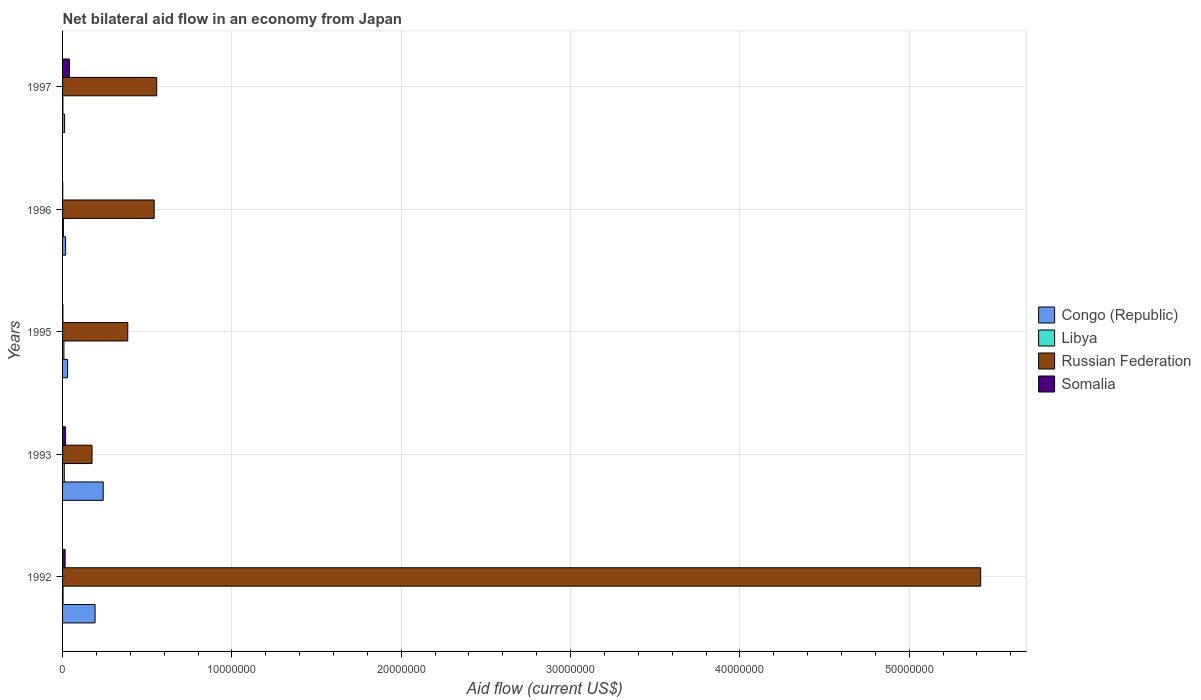How many bars are there on the 3rd tick from the bottom?
Keep it short and to the point. 4. What is the net bilateral aid flow in Congo (Republic) in 1996?
Ensure brevity in your answer.  1.80e+05. Across all years, what is the maximum net bilateral aid flow in Congo (Republic)?
Your response must be concise. 2.40e+06. In which year was the net bilateral aid flow in Russian Federation minimum?
Your response must be concise. 1993. What is the total net bilateral aid flow in Congo (Republic) in the graph?
Your answer should be compact. 4.92e+06. What is the average net bilateral aid flow in Russian Federation per year?
Ensure brevity in your answer.  1.42e+07. In the year 1993, what is the difference between the net bilateral aid flow in Congo (Republic) and net bilateral aid flow in Libya?
Offer a very short reply. 2.30e+06. In how many years, is the net bilateral aid flow in Russian Federation greater than 46000000 US$?
Your answer should be compact. 1. What is the ratio of the net bilateral aid flow in Congo (Republic) in 1993 to that in 1995?
Provide a short and direct response. 8. Is the net bilateral aid flow in Russian Federation in 1992 less than that in 1996?
Provide a short and direct response. No. What is the difference between the highest and the second highest net bilateral aid flow in Russian Federation?
Provide a short and direct response. 4.87e+07. What is the difference between the highest and the lowest net bilateral aid flow in Libya?
Your answer should be compact. 8.00e+04. Is the sum of the net bilateral aid flow in Russian Federation in 1992 and 1995 greater than the maximum net bilateral aid flow in Libya across all years?
Make the answer very short. Yes. Is it the case that in every year, the sum of the net bilateral aid flow in Somalia and net bilateral aid flow in Congo (Republic) is greater than the sum of net bilateral aid flow in Libya and net bilateral aid flow in Russian Federation?
Give a very brief answer. Yes. What does the 1st bar from the top in 1995 represents?
Provide a short and direct response. Somalia. What does the 4th bar from the bottom in 1995 represents?
Make the answer very short. Somalia. Are all the bars in the graph horizontal?
Make the answer very short. Yes. Are the values on the major ticks of X-axis written in scientific E-notation?
Your response must be concise. No. Does the graph contain any zero values?
Make the answer very short. No. How are the legend labels stacked?
Your answer should be very brief. Vertical. What is the title of the graph?
Make the answer very short. Net bilateral aid flow in an economy from Japan. Does "Namibia" appear as one of the legend labels in the graph?
Your response must be concise. No. What is the Aid flow (current US$) in Congo (Republic) in 1992?
Your answer should be very brief. 1.92e+06. What is the Aid flow (current US$) of Libya in 1992?
Make the answer very short. 3.00e+04. What is the Aid flow (current US$) in Russian Federation in 1992?
Your answer should be very brief. 5.42e+07. What is the Aid flow (current US$) of Somalia in 1992?
Offer a terse response. 1.50e+05. What is the Aid flow (current US$) in Congo (Republic) in 1993?
Your answer should be very brief. 2.40e+06. What is the Aid flow (current US$) in Libya in 1993?
Keep it short and to the point. 1.00e+05. What is the Aid flow (current US$) of Russian Federation in 1993?
Your answer should be very brief. 1.74e+06. What is the Aid flow (current US$) of Congo (Republic) in 1995?
Ensure brevity in your answer.  3.00e+05. What is the Aid flow (current US$) in Libya in 1995?
Keep it short and to the point. 8.00e+04. What is the Aid flow (current US$) of Russian Federation in 1995?
Provide a short and direct response. 3.85e+06. What is the Aid flow (current US$) of Congo (Republic) in 1996?
Make the answer very short. 1.80e+05. What is the Aid flow (current US$) of Libya in 1996?
Keep it short and to the point. 5.00e+04. What is the Aid flow (current US$) in Russian Federation in 1996?
Keep it short and to the point. 5.41e+06. What is the Aid flow (current US$) of Somalia in 1996?
Give a very brief answer. 10000. What is the Aid flow (current US$) in Russian Federation in 1997?
Provide a short and direct response. 5.56e+06. Across all years, what is the maximum Aid flow (current US$) of Congo (Republic)?
Your answer should be compact. 2.40e+06. Across all years, what is the maximum Aid flow (current US$) in Russian Federation?
Provide a succinct answer. 5.42e+07. Across all years, what is the maximum Aid flow (current US$) in Somalia?
Offer a terse response. 4.00e+05. Across all years, what is the minimum Aid flow (current US$) of Russian Federation?
Your response must be concise. 1.74e+06. What is the total Aid flow (current US$) in Congo (Republic) in the graph?
Offer a very short reply. 4.92e+06. What is the total Aid flow (current US$) of Libya in the graph?
Your answer should be compact. 2.80e+05. What is the total Aid flow (current US$) of Russian Federation in the graph?
Keep it short and to the point. 7.08e+07. What is the total Aid flow (current US$) of Somalia in the graph?
Your answer should be very brief. 7.60e+05. What is the difference between the Aid flow (current US$) in Congo (Republic) in 1992 and that in 1993?
Give a very brief answer. -4.80e+05. What is the difference between the Aid flow (current US$) in Russian Federation in 1992 and that in 1993?
Give a very brief answer. 5.25e+07. What is the difference between the Aid flow (current US$) in Somalia in 1992 and that in 1993?
Provide a succinct answer. -3.00e+04. What is the difference between the Aid flow (current US$) in Congo (Republic) in 1992 and that in 1995?
Keep it short and to the point. 1.62e+06. What is the difference between the Aid flow (current US$) in Libya in 1992 and that in 1995?
Your answer should be very brief. -5.00e+04. What is the difference between the Aid flow (current US$) in Russian Federation in 1992 and that in 1995?
Provide a short and direct response. 5.04e+07. What is the difference between the Aid flow (current US$) in Congo (Republic) in 1992 and that in 1996?
Give a very brief answer. 1.74e+06. What is the difference between the Aid flow (current US$) of Libya in 1992 and that in 1996?
Keep it short and to the point. -2.00e+04. What is the difference between the Aid flow (current US$) in Russian Federation in 1992 and that in 1996?
Your response must be concise. 4.88e+07. What is the difference between the Aid flow (current US$) in Congo (Republic) in 1992 and that in 1997?
Keep it short and to the point. 1.80e+06. What is the difference between the Aid flow (current US$) in Russian Federation in 1992 and that in 1997?
Your response must be concise. 4.87e+07. What is the difference between the Aid flow (current US$) of Somalia in 1992 and that in 1997?
Give a very brief answer. -2.50e+05. What is the difference between the Aid flow (current US$) in Congo (Republic) in 1993 and that in 1995?
Keep it short and to the point. 2.10e+06. What is the difference between the Aid flow (current US$) in Russian Federation in 1993 and that in 1995?
Your answer should be compact. -2.11e+06. What is the difference between the Aid flow (current US$) in Somalia in 1993 and that in 1995?
Ensure brevity in your answer.  1.60e+05. What is the difference between the Aid flow (current US$) in Congo (Republic) in 1993 and that in 1996?
Provide a short and direct response. 2.22e+06. What is the difference between the Aid flow (current US$) of Libya in 1993 and that in 1996?
Ensure brevity in your answer.  5.00e+04. What is the difference between the Aid flow (current US$) of Russian Federation in 1993 and that in 1996?
Make the answer very short. -3.67e+06. What is the difference between the Aid flow (current US$) of Congo (Republic) in 1993 and that in 1997?
Your answer should be compact. 2.28e+06. What is the difference between the Aid flow (current US$) of Russian Federation in 1993 and that in 1997?
Your answer should be compact. -3.82e+06. What is the difference between the Aid flow (current US$) of Congo (Republic) in 1995 and that in 1996?
Your response must be concise. 1.20e+05. What is the difference between the Aid flow (current US$) in Russian Federation in 1995 and that in 1996?
Your answer should be very brief. -1.56e+06. What is the difference between the Aid flow (current US$) of Somalia in 1995 and that in 1996?
Your answer should be very brief. 10000. What is the difference between the Aid flow (current US$) of Congo (Republic) in 1995 and that in 1997?
Ensure brevity in your answer.  1.80e+05. What is the difference between the Aid flow (current US$) of Libya in 1995 and that in 1997?
Offer a very short reply. 6.00e+04. What is the difference between the Aid flow (current US$) in Russian Federation in 1995 and that in 1997?
Keep it short and to the point. -1.71e+06. What is the difference between the Aid flow (current US$) in Somalia in 1995 and that in 1997?
Your response must be concise. -3.80e+05. What is the difference between the Aid flow (current US$) in Congo (Republic) in 1996 and that in 1997?
Offer a very short reply. 6.00e+04. What is the difference between the Aid flow (current US$) of Libya in 1996 and that in 1997?
Keep it short and to the point. 3.00e+04. What is the difference between the Aid flow (current US$) of Somalia in 1996 and that in 1997?
Provide a succinct answer. -3.90e+05. What is the difference between the Aid flow (current US$) of Congo (Republic) in 1992 and the Aid flow (current US$) of Libya in 1993?
Ensure brevity in your answer.  1.82e+06. What is the difference between the Aid flow (current US$) in Congo (Republic) in 1992 and the Aid flow (current US$) in Somalia in 1993?
Offer a terse response. 1.74e+06. What is the difference between the Aid flow (current US$) of Libya in 1992 and the Aid flow (current US$) of Russian Federation in 1993?
Keep it short and to the point. -1.71e+06. What is the difference between the Aid flow (current US$) in Libya in 1992 and the Aid flow (current US$) in Somalia in 1993?
Offer a terse response. -1.50e+05. What is the difference between the Aid flow (current US$) in Russian Federation in 1992 and the Aid flow (current US$) in Somalia in 1993?
Keep it short and to the point. 5.40e+07. What is the difference between the Aid flow (current US$) in Congo (Republic) in 1992 and the Aid flow (current US$) in Libya in 1995?
Your answer should be compact. 1.84e+06. What is the difference between the Aid flow (current US$) of Congo (Republic) in 1992 and the Aid flow (current US$) of Russian Federation in 1995?
Ensure brevity in your answer.  -1.93e+06. What is the difference between the Aid flow (current US$) in Congo (Republic) in 1992 and the Aid flow (current US$) in Somalia in 1995?
Your answer should be very brief. 1.90e+06. What is the difference between the Aid flow (current US$) in Libya in 1992 and the Aid flow (current US$) in Russian Federation in 1995?
Your response must be concise. -3.82e+06. What is the difference between the Aid flow (current US$) of Russian Federation in 1992 and the Aid flow (current US$) of Somalia in 1995?
Offer a terse response. 5.42e+07. What is the difference between the Aid flow (current US$) in Congo (Republic) in 1992 and the Aid flow (current US$) in Libya in 1996?
Offer a very short reply. 1.87e+06. What is the difference between the Aid flow (current US$) in Congo (Republic) in 1992 and the Aid flow (current US$) in Russian Federation in 1996?
Give a very brief answer. -3.49e+06. What is the difference between the Aid flow (current US$) in Congo (Republic) in 1992 and the Aid flow (current US$) in Somalia in 1996?
Your answer should be compact. 1.91e+06. What is the difference between the Aid flow (current US$) of Libya in 1992 and the Aid flow (current US$) of Russian Federation in 1996?
Offer a very short reply. -5.38e+06. What is the difference between the Aid flow (current US$) of Libya in 1992 and the Aid flow (current US$) of Somalia in 1996?
Provide a short and direct response. 2.00e+04. What is the difference between the Aid flow (current US$) in Russian Federation in 1992 and the Aid flow (current US$) in Somalia in 1996?
Offer a very short reply. 5.42e+07. What is the difference between the Aid flow (current US$) of Congo (Republic) in 1992 and the Aid flow (current US$) of Libya in 1997?
Provide a succinct answer. 1.90e+06. What is the difference between the Aid flow (current US$) in Congo (Republic) in 1992 and the Aid flow (current US$) in Russian Federation in 1997?
Keep it short and to the point. -3.64e+06. What is the difference between the Aid flow (current US$) in Congo (Republic) in 1992 and the Aid flow (current US$) in Somalia in 1997?
Your answer should be very brief. 1.52e+06. What is the difference between the Aid flow (current US$) of Libya in 1992 and the Aid flow (current US$) of Russian Federation in 1997?
Keep it short and to the point. -5.53e+06. What is the difference between the Aid flow (current US$) in Libya in 1992 and the Aid flow (current US$) in Somalia in 1997?
Keep it short and to the point. -3.70e+05. What is the difference between the Aid flow (current US$) in Russian Federation in 1992 and the Aid flow (current US$) in Somalia in 1997?
Your answer should be very brief. 5.38e+07. What is the difference between the Aid flow (current US$) of Congo (Republic) in 1993 and the Aid flow (current US$) of Libya in 1995?
Offer a very short reply. 2.32e+06. What is the difference between the Aid flow (current US$) in Congo (Republic) in 1993 and the Aid flow (current US$) in Russian Federation in 1995?
Your answer should be very brief. -1.45e+06. What is the difference between the Aid flow (current US$) of Congo (Republic) in 1993 and the Aid flow (current US$) of Somalia in 1995?
Offer a terse response. 2.38e+06. What is the difference between the Aid flow (current US$) in Libya in 1993 and the Aid flow (current US$) in Russian Federation in 1995?
Offer a terse response. -3.75e+06. What is the difference between the Aid flow (current US$) in Russian Federation in 1993 and the Aid flow (current US$) in Somalia in 1995?
Provide a short and direct response. 1.72e+06. What is the difference between the Aid flow (current US$) in Congo (Republic) in 1993 and the Aid flow (current US$) in Libya in 1996?
Ensure brevity in your answer.  2.35e+06. What is the difference between the Aid flow (current US$) of Congo (Republic) in 1993 and the Aid flow (current US$) of Russian Federation in 1996?
Provide a succinct answer. -3.01e+06. What is the difference between the Aid flow (current US$) of Congo (Republic) in 1993 and the Aid flow (current US$) of Somalia in 1996?
Your response must be concise. 2.39e+06. What is the difference between the Aid flow (current US$) in Libya in 1993 and the Aid flow (current US$) in Russian Federation in 1996?
Ensure brevity in your answer.  -5.31e+06. What is the difference between the Aid flow (current US$) of Russian Federation in 1993 and the Aid flow (current US$) of Somalia in 1996?
Provide a succinct answer. 1.73e+06. What is the difference between the Aid flow (current US$) in Congo (Republic) in 1993 and the Aid flow (current US$) in Libya in 1997?
Provide a succinct answer. 2.38e+06. What is the difference between the Aid flow (current US$) in Congo (Republic) in 1993 and the Aid flow (current US$) in Russian Federation in 1997?
Your answer should be compact. -3.16e+06. What is the difference between the Aid flow (current US$) in Congo (Republic) in 1993 and the Aid flow (current US$) in Somalia in 1997?
Offer a terse response. 2.00e+06. What is the difference between the Aid flow (current US$) in Libya in 1993 and the Aid flow (current US$) in Russian Federation in 1997?
Provide a short and direct response. -5.46e+06. What is the difference between the Aid flow (current US$) of Russian Federation in 1993 and the Aid flow (current US$) of Somalia in 1997?
Your answer should be very brief. 1.34e+06. What is the difference between the Aid flow (current US$) of Congo (Republic) in 1995 and the Aid flow (current US$) of Russian Federation in 1996?
Your answer should be compact. -5.11e+06. What is the difference between the Aid flow (current US$) of Libya in 1995 and the Aid flow (current US$) of Russian Federation in 1996?
Your answer should be compact. -5.33e+06. What is the difference between the Aid flow (current US$) of Libya in 1995 and the Aid flow (current US$) of Somalia in 1996?
Your answer should be compact. 7.00e+04. What is the difference between the Aid flow (current US$) of Russian Federation in 1995 and the Aid flow (current US$) of Somalia in 1996?
Keep it short and to the point. 3.84e+06. What is the difference between the Aid flow (current US$) of Congo (Republic) in 1995 and the Aid flow (current US$) of Russian Federation in 1997?
Make the answer very short. -5.26e+06. What is the difference between the Aid flow (current US$) in Libya in 1995 and the Aid flow (current US$) in Russian Federation in 1997?
Keep it short and to the point. -5.48e+06. What is the difference between the Aid flow (current US$) in Libya in 1995 and the Aid flow (current US$) in Somalia in 1997?
Offer a terse response. -3.20e+05. What is the difference between the Aid flow (current US$) of Russian Federation in 1995 and the Aid flow (current US$) of Somalia in 1997?
Keep it short and to the point. 3.45e+06. What is the difference between the Aid flow (current US$) in Congo (Republic) in 1996 and the Aid flow (current US$) in Russian Federation in 1997?
Offer a terse response. -5.38e+06. What is the difference between the Aid flow (current US$) of Libya in 1996 and the Aid flow (current US$) of Russian Federation in 1997?
Your response must be concise. -5.51e+06. What is the difference between the Aid flow (current US$) in Libya in 1996 and the Aid flow (current US$) in Somalia in 1997?
Ensure brevity in your answer.  -3.50e+05. What is the difference between the Aid flow (current US$) in Russian Federation in 1996 and the Aid flow (current US$) in Somalia in 1997?
Provide a short and direct response. 5.01e+06. What is the average Aid flow (current US$) of Congo (Republic) per year?
Your response must be concise. 9.84e+05. What is the average Aid flow (current US$) of Libya per year?
Make the answer very short. 5.60e+04. What is the average Aid flow (current US$) in Russian Federation per year?
Your answer should be compact. 1.42e+07. What is the average Aid flow (current US$) in Somalia per year?
Give a very brief answer. 1.52e+05. In the year 1992, what is the difference between the Aid flow (current US$) in Congo (Republic) and Aid flow (current US$) in Libya?
Your answer should be compact. 1.89e+06. In the year 1992, what is the difference between the Aid flow (current US$) of Congo (Republic) and Aid flow (current US$) of Russian Federation?
Give a very brief answer. -5.23e+07. In the year 1992, what is the difference between the Aid flow (current US$) of Congo (Republic) and Aid flow (current US$) of Somalia?
Keep it short and to the point. 1.77e+06. In the year 1992, what is the difference between the Aid flow (current US$) in Libya and Aid flow (current US$) in Russian Federation?
Your answer should be very brief. -5.42e+07. In the year 1992, what is the difference between the Aid flow (current US$) of Russian Federation and Aid flow (current US$) of Somalia?
Your answer should be very brief. 5.41e+07. In the year 1993, what is the difference between the Aid flow (current US$) in Congo (Republic) and Aid flow (current US$) in Libya?
Ensure brevity in your answer.  2.30e+06. In the year 1993, what is the difference between the Aid flow (current US$) in Congo (Republic) and Aid flow (current US$) in Somalia?
Offer a terse response. 2.22e+06. In the year 1993, what is the difference between the Aid flow (current US$) in Libya and Aid flow (current US$) in Russian Federation?
Provide a succinct answer. -1.64e+06. In the year 1993, what is the difference between the Aid flow (current US$) of Libya and Aid flow (current US$) of Somalia?
Provide a succinct answer. -8.00e+04. In the year 1993, what is the difference between the Aid flow (current US$) in Russian Federation and Aid flow (current US$) in Somalia?
Your response must be concise. 1.56e+06. In the year 1995, what is the difference between the Aid flow (current US$) in Congo (Republic) and Aid flow (current US$) in Russian Federation?
Your answer should be very brief. -3.55e+06. In the year 1995, what is the difference between the Aid flow (current US$) of Libya and Aid flow (current US$) of Russian Federation?
Provide a succinct answer. -3.77e+06. In the year 1995, what is the difference between the Aid flow (current US$) of Libya and Aid flow (current US$) of Somalia?
Offer a very short reply. 6.00e+04. In the year 1995, what is the difference between the Aid flow (current US$) in Russian Federation and Aid flow (current US$) in Somalia?
Your response must be concise. 3.83e+06. In the year 1996, what is the difference between the Aid flow (current US$) in Congo (Republic) and Aid flow (current US$) in Libya?
Offer a very short reply. 1.30e+05. In the year 1996, what is the difference between the Aid flow (current US$) of Congo (Republic) and Aid flow (current US$) of Russian Federation?
Keep it short and to the point. -5.23e+06. In the year 1996, what is the difference between the Aid flow (current US$) in Congo (Republic) and Aid flow (current US$) in Somalia?
Ensure brevity in your answer.  1.70e+05. In the year 1996, what is the difference between the Aid flow (current US$) of Libya and Aid flow (current US$) of Russian Federation?
Your answer should be very brief. -5.36e+06. In the year 1996, what is the difference between the Aid flow (current US$) in Russian Federation and Aid flow (current US$) in Somalia?
Ensure brevity in your answer.  5.40e+06. In the year 1997, what is the difference between the Aid flow (current US$) of Congo (Republic) and Aid flow (current US$) of Russian Federation?
Provide a succinct answer. -5.44e+06. In the year 1997, what is the difference between the Aid flow (current US$) in Congo (Republic) and Aid flow (current US$) in Somalia?
Your response must be concise. -2.80e+05. In the year 1997, what is the difference between the Aid flow (current US$) of Libya and Aid flow (current US$) of Russian Federation?
Offer a very short reply. -5.54e+06. In the year 1997, what is the difference between the Aid flow (current US$) of Libya and Aid flow (current US$) of Somalia?
Keep it short and to the point. -3.80e+05. In the year 1997, what is the difference between the Aid flow (current US$) in Russian Federation and Aid flow (current US$) in Somalia?
Offer a very short reply. 5.16e+06. What is the ratio of the Aid flow (current US$) of Congo (Republic) in 1992 to that in 1993?
Keep it short and to the point. 0.8. What is the ratio of the Aid flow (current US$) in Russian Federation in 1992 to that in 1993?
Make the answer very short. 31.16. What is the ratio of the Aid flow (current US$) in Russian Federation in 1992 to that in 1995?
Make the answer very short. 14.08. What is the ratio of the Aid flow (current US$) in Somalia in 1992 to that in 1995?
Provide a succinct answer. 7.5. What is the ratio of the Aid flow (current US$) in Congo (Republic) in 1992 to that in 1996?
Your answer should be very brief. 10.67. What is the ratio of the Aid flow (current US$) in Russian Federation in 1992 to that in 1996?
Ensure brevity in your answer.  10.02. What is the ratio of the Aid flow (current US$) of Congo (Republic) in 1992 to that in 1997?
Offer a terse response. 16. What is the ratio of the Aid flow (current US$) of Russian Federation in 1992 to that in 1997?
Give a very brief answer. 9.75. What is the ratio of the Aid flow (current US$) in Somalia in 1992 to that in 1997?
Provide a short and direct response. 0.38. What is the ratio of the Aid flow (current US$) of Russian Federation in 1993 to that in 1995?
Make the answer very short. 0.45. What is the ratio of the Aid flow (current US$) of Somalia in 1993 to that in 1995?
Make the answer very short. 9. What is the ratio of the Aid flow (current US$) of Congo (Republic) in 1993 to that in 1996?
Your answer should be very brief. 13.33. What is the ratio of the Aid flow (current US$) of Libya in 1993 to that in 1996?
Your answer should be very brief. 2. What is the ratio of the Aid flow (current US$) of Russian Federation in 1993 to that in 1996?
Keep it short and to the point. 0.32. What is the ratio of the Aid flow (current US$) in Somalia in 1993 to that in 1996?
Keep it short and to the point. 18. What is the ratio of the Aid flow (current US$) in Libya in 1993 to that in 1997?
Give a very brief answer. 5. What is the ratio of the Aid flow (current US$) in Russian Federation in 1993 to that in 1997?
Provide a short and direct response. 0.31. What is the ratio of the Aid flow (current US$) in Somalia in 1993 to that in 1997?
Provide a succinct answer. 0.45. What is the ratio of the Aid flow (current US$) in Libya in 1995 to that in 1996?
Offer a terse response. 1.6. What is the ratio of the Aid flow (current US$) of Russian Federation in 1995 to that in 1996?
Keep it short and to the point. 0.71. What is the ratio of the Aid flow (current US$) of Somalia in 1995 to that in 1996?
Your answer should be very brief. 2. What is the ratio of the Aid flow (current US$) in Congo (Republic) in 1995 to that in 1997?
Your answer should be very brief. 2.5. What is the ratio of the Aid flow (current US$) in Russian Federation in 1995 to that in 1997?
Keep it short and to the point. 0.69. What is the ratio of the Aid flow (current US$) of Congo (Republic) in 1996 to that in 1997?
Keep it short and to the point. 1.5. What is the ratio of the Aid flow (current US$) of Russian Federation in 1996 to that in 1997?
Ensure brevity in your answer.  0.97. What is the ratio of the Aid flow (current US$) in Somalia in 1996 to that in 1997?
Ensure brevity in your answer.  0.03. What is the difference between the highest and the second highest Aid flow (current US$) of Libya?
Provide a short and direct response. 2.00e+04. What is the difference between the highest and the second highest Aid flow (current US$) in Russian Federation?
Keep it short and to the point. 4.87e+07. What is the difference between the highest and the lowest Aid flow (current US$) in Congo (Republic)?
Provide a short and direct response. 2.28e+06. What is the difference between the highest and the lowest Aid flow (current US$) in Russian Federation?
Provide a short and direct response. 5.25e+07. What is the difference between the highest and the lowest Aid flow (current US$) in Somalia?
Offer a terse response. 3.90e+05. 